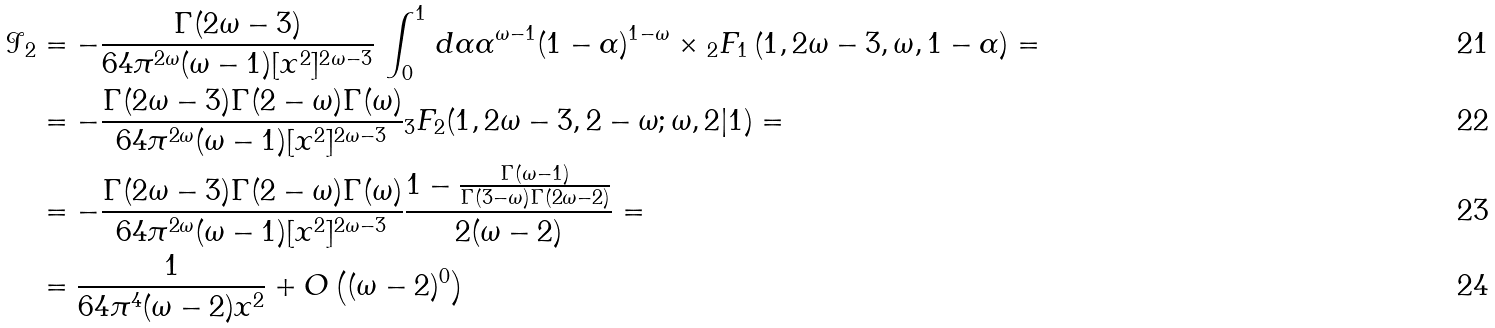Convert formula to latex. <formula><loc_0><loc_0><loc_500><loc_500>\mathcal { I } _ { 2 } & = - \frac { \Gamma ( 2 \omega - 3 ) } { 6 4 \pi ^ { 2 \omega } ( \omega - 1 ) [ { x } ^ { 2 } ] ^ { 2 \omega - 3 } } \, \int _ { 0 } ^ { 1 } \, d \alpha { \alpha ^ { \omega - 1 } ( 1 - \alpha ) ^ { 1 - \omega } } \times { _ { 2 } F _ { 1 } } \left ( 1 , 2 \omega - 3 , \omega , 1 - \alpha \right ) = \\ & = - \frac { \Gamma ( 2 \omega - 3 ) \Gamma ( 2 - \omega ) \Gamma ( \omega ) } { 6 4 \pi ^ { 2 \omega } ( \omega - 1 ) [ { x } ^ { 2 } ] ^ { 2 \omega - 3 } } { _ { 3 } F _ { 2 } } ( 1 , 2 \omega - 3 , 2 - \omega ; \omega , 2 | 1 ) = \\ & = - \frac { \Gamma ( 2 \omega - 3 ) \Gamma ( 2 - \omega ) \Gamma ( \omega ) } { 6 4 \pi ^ { 2 \omega } ( \omega - 1 ) [ { x } ^ { 2 } ] ^ { 2 \omega - 3 } } \frac { 1 - \frac { \Gamma ( \omega - 1 ) } { \Gamma ( 3 - \omega ) \Gamma ( 2 \omega - 2 ) } } { 2 ( \omega - 2 ) } = \\ & = \frac { 1 } { 6 4 \pi ^ { 4 } ( \omega - 2 ) { x } ^ { 2 } } + O \left ( ( \omega - 2 ) ^ { 0 } \right )</formula> 